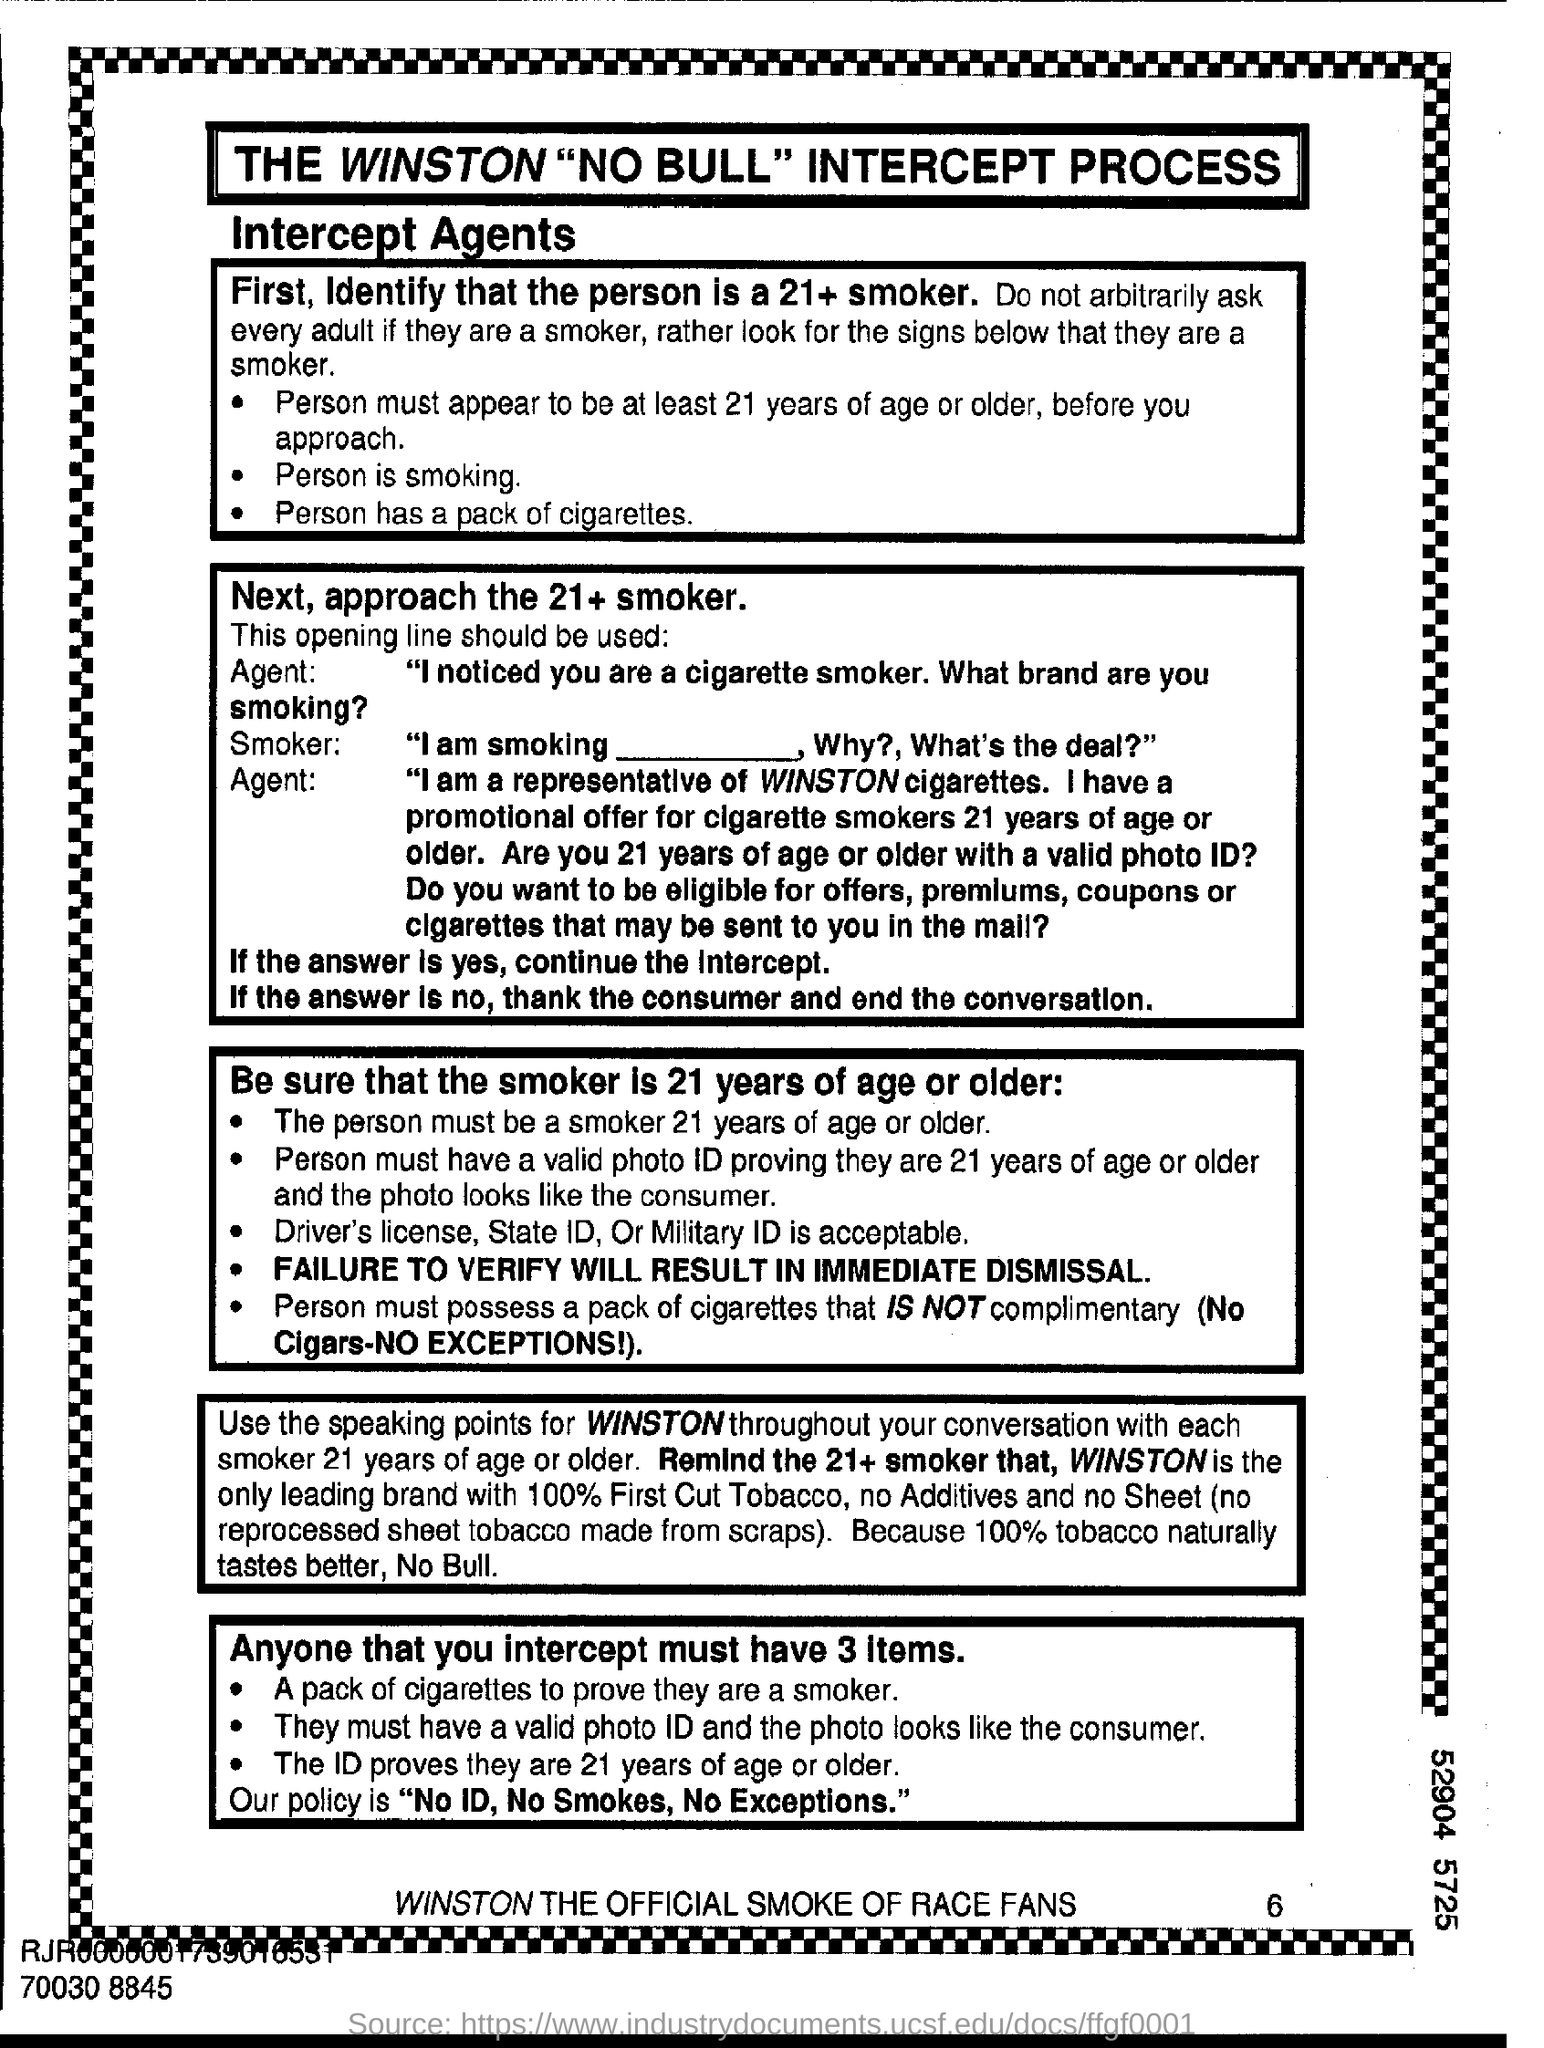What are the acceptable ID's for a smoker of age 21+ years?
Offer a terse response. Driver's license , state id , or military id. 